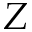Convert formula to latex. <formula><loc_0><loc_0><loc_500><loc_500>Z</formula> 